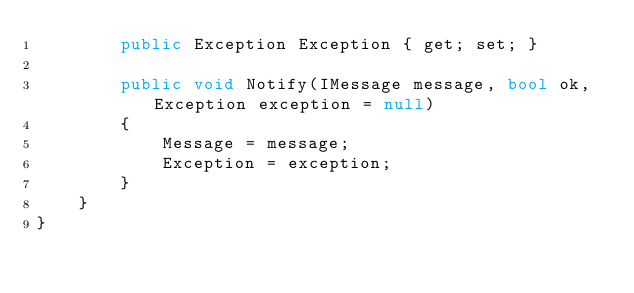Convert code to text. <code><loc_0><loc_0><loc_500><loc_500><_C#_>        public Exception Exception { get; set; }
   
        public void Notify(IMessage message, bool ok, Exception exception = null)
        {
            Message = message;
            Exception = exception;
        }
    }
}</code> 